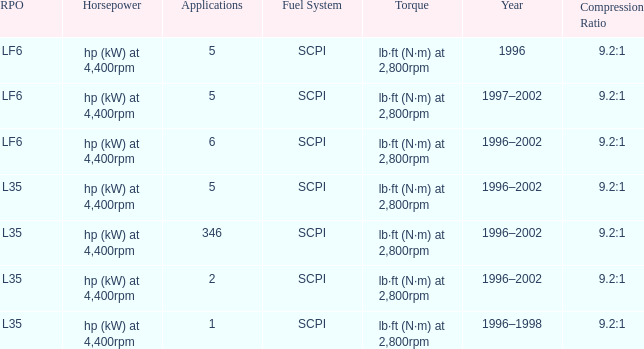What's the compression ratio of the model with L35 RPO and 5 applications? 9.2:1. 